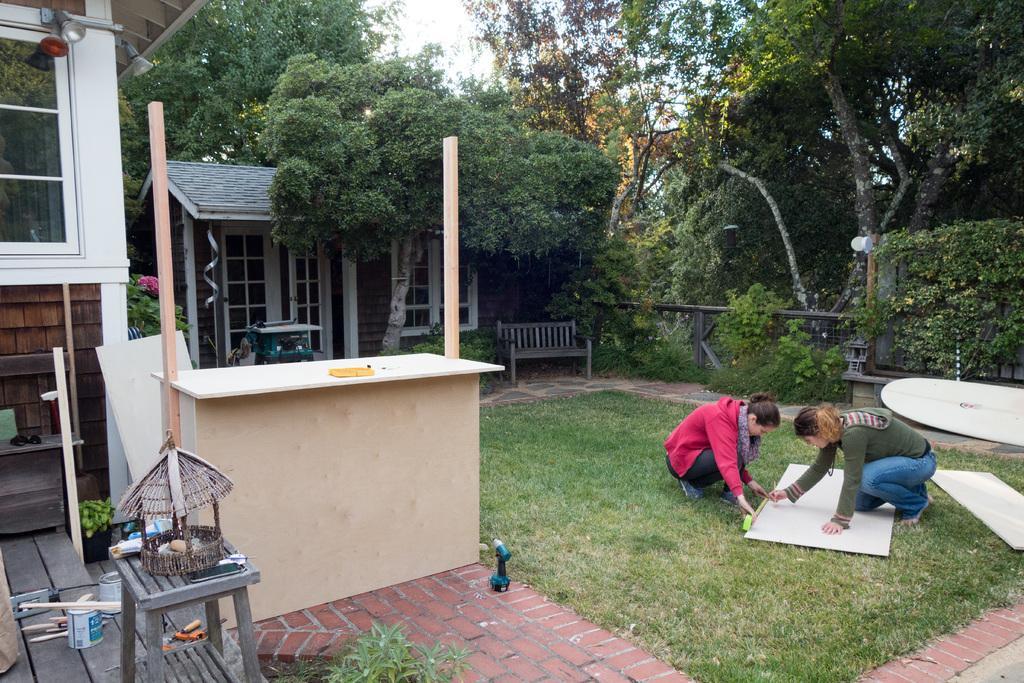Please provide a concise description of this image. In this image we can see these two persons are in the squat position, here we can see the board, the grass, a table, stool, some objects, plants, glass windows, light, houses, wooden bench, fence, trees and the sky in the background. 